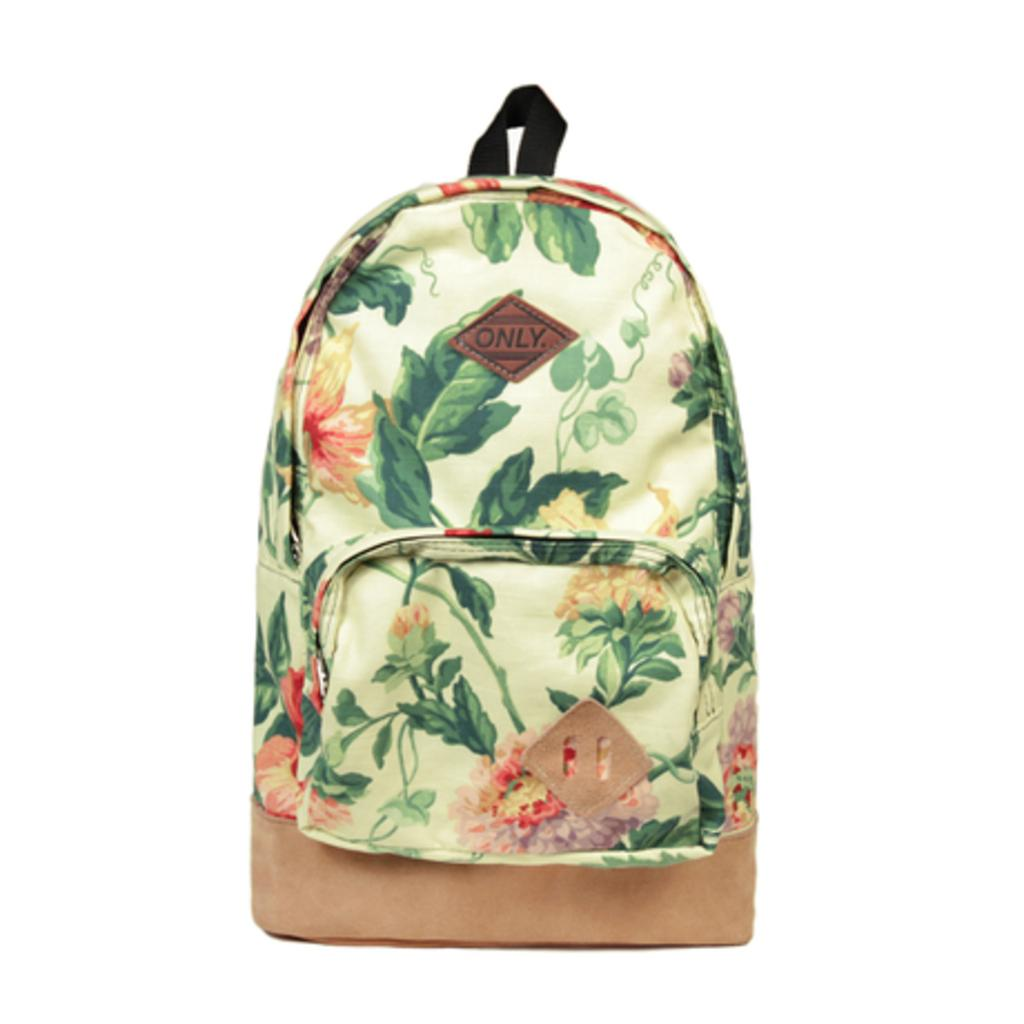Provide a one-sentence caption for the provided image. An "Only" brand floral backpack with a front zipper pocket. 